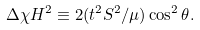<formula> <loc_0><loc_0><loc_500><loc_500>\Delta \chi H ^ { 2 } \equiv 2 ( t ^ { 2 } S ^ { 2 } / \mu ) \cos ^ { 2 } \theta .</formula> 